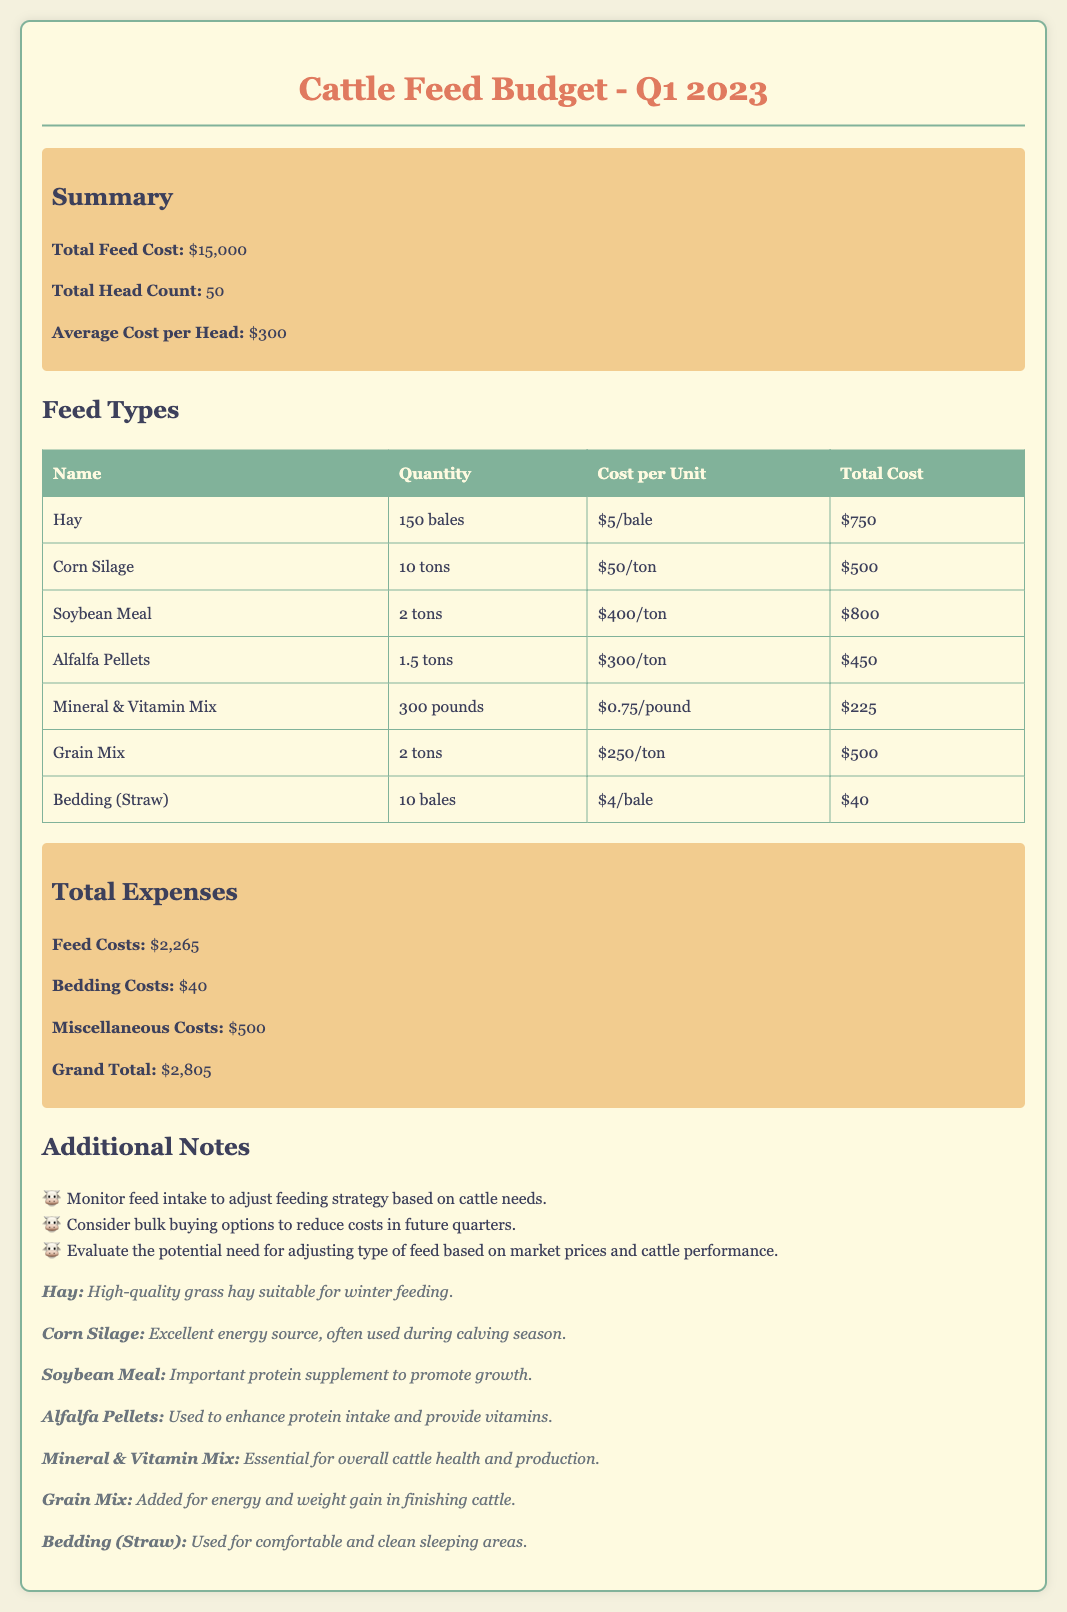what is the total feed cost? The total feed cost is stated in the summary section of the document.
Answer: $15,000 how many head of cattle are there? The total head count is provided in the summary section as well.
Answer: 50 what is the cost per head? The average cost per head is also mentioned in the summary section.
Answer: $300 how much does Hay cost in total? The total cost for Hay can be found in the feed types table.
Answer: $750 which feed type has the highest cost per unit? The feed type with the highest cost per unit is determined by comparing the unit costs in the feed types table.
Answer: Soybean Meal what is the total bedding cost? The total bedding cost is presented in the total expenses section.
Answer: $40 how many tons of Corn Silage are purchased? The quantity of Corn Silage can be seen in the feed types table.
Answer: 10 tons what is the grand total of all expenses? The grand total is recorded in the total expenses section of the document.
Answer: $2,805 what is the total quantity of Mineral & Vitamin Mix? The quantity of Mineral & Vitamin Mix is detailed in the feed types table.
Answer: 300 pounds 